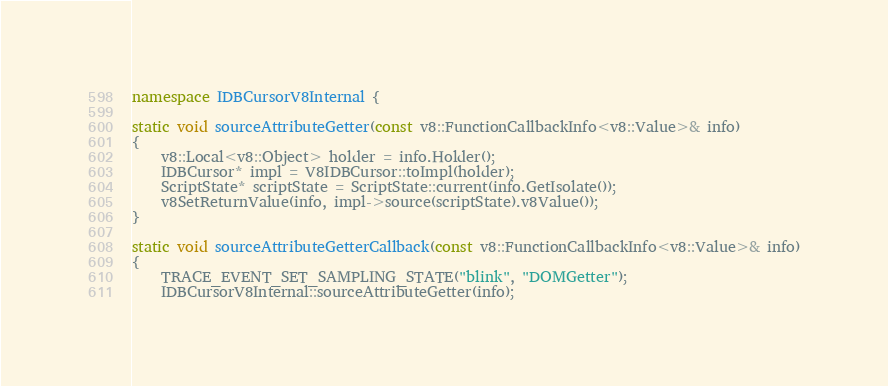Convert code to text. <code><loc_0><loc_0><loc_500><loc_500><_C++_>namespace IDBCursorV8Internal {

static void sourceAttributeGetter(const v8::FunctionCallbackInfo<v8::Value>& info)
{
    v8::Local<v8::Object> holder = info.Holder();
    IDBCursor* impl = V8IDBCursor::toImpl(holder);
    ScriptState* scriptState = ScriptState::current(info.GetIsolate());
    v8SetReturnValue(info, impl->source(scriptState).v8Value());
}

static void sourceAttributeGetterCallback(const v8::FunctionCallbackInfo<v8::Value>& info)
{
    TRACE_EVENT_SET_SAMPLING_STATE("blink", "DOMGetter");
    IDBCursorV8Internal::sourceAttributeGetter(info);</code> 